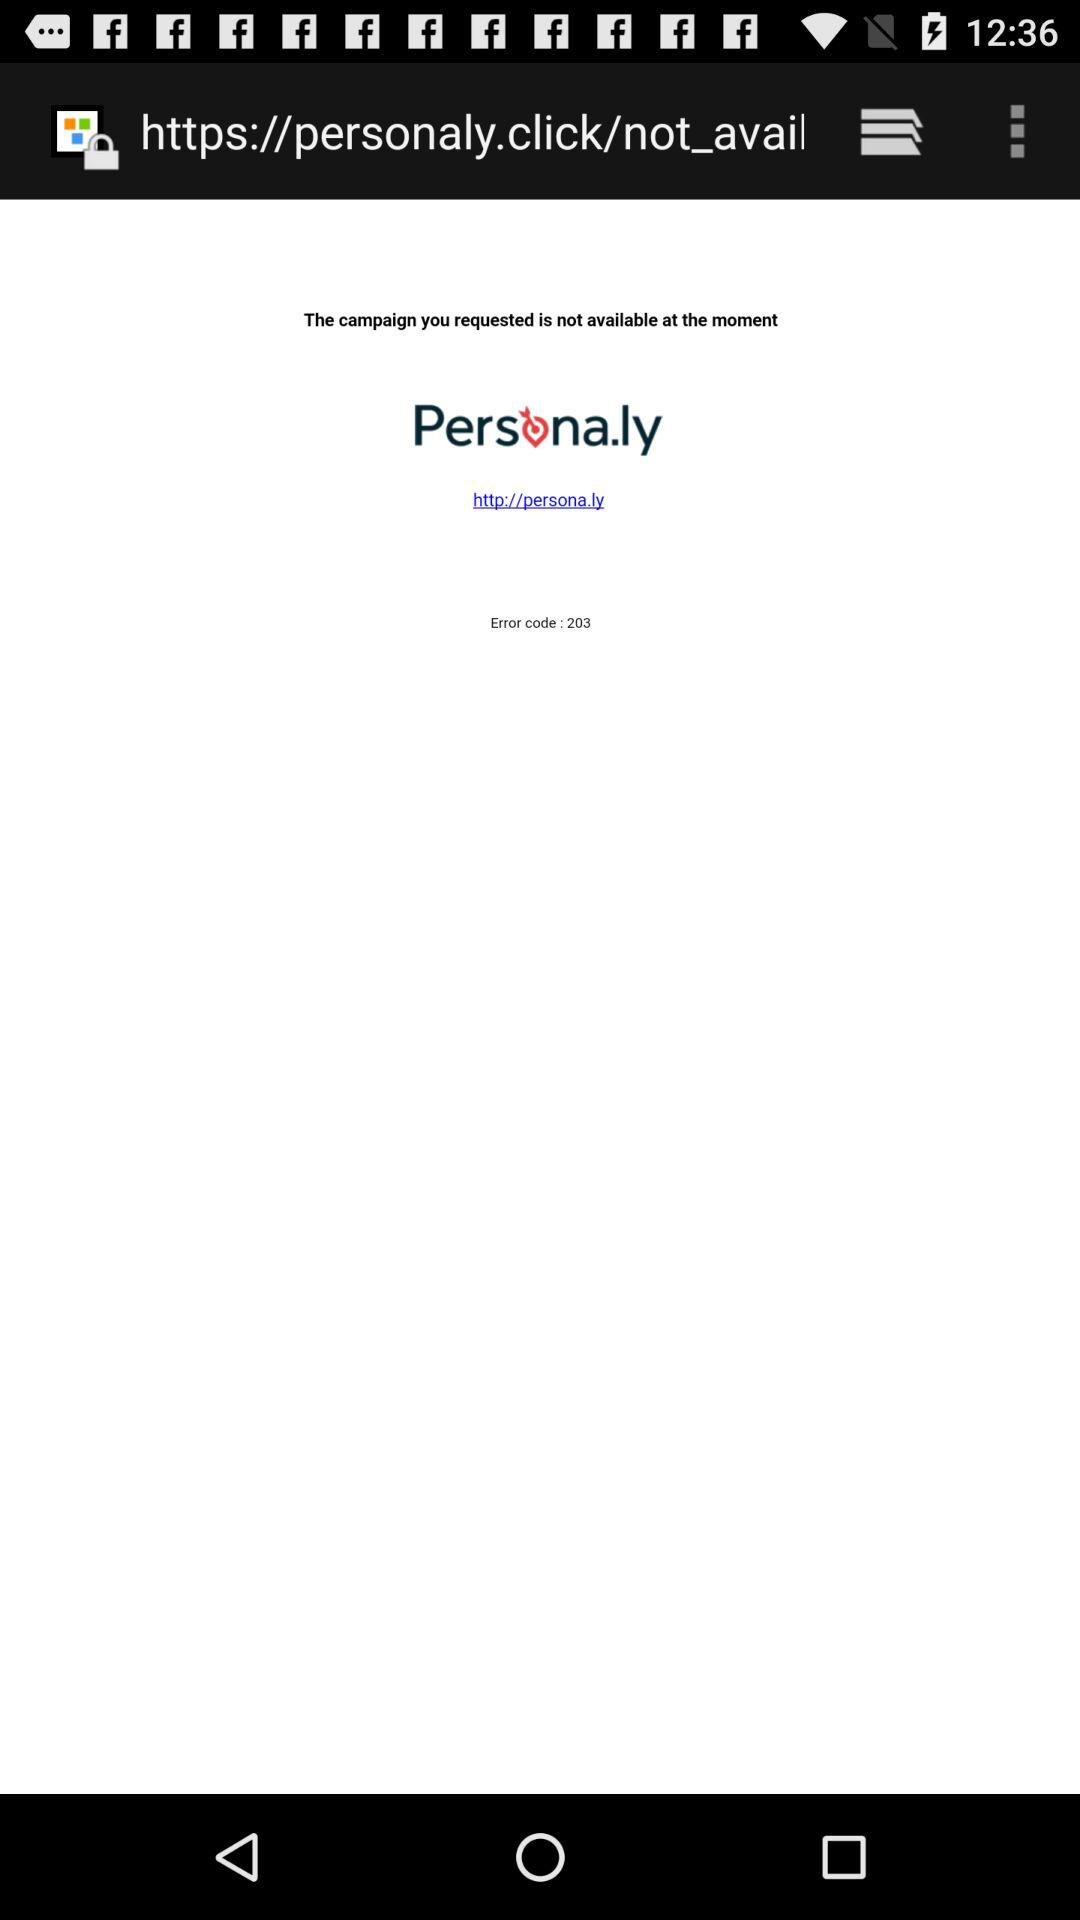What is the application name? The application name is "Persona.ly". 